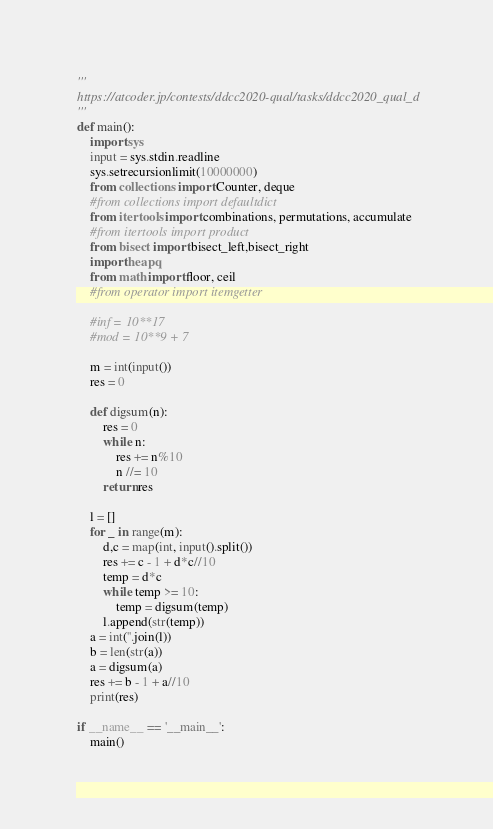Convert code to text. <code><loc_0><loc_0><loc_500><loc_500><_Python_>'''
https://atcoder.jp/contests/ddcc2020-qual/tasks/ddcc2020_qual_d
'''
def main():
    import sys
    input = sys.stdin.readline
    sys.setrecursionlimit(10000000)
    from collections import Counter, deque
    #from collections import defaultdict
    from itertools import combinations, permutations, accumulate
    #from itertools import product
    from bisect import bisect_left,bisect_right
    import heapq
    from math import floor, ceil
    #from operator import itemgetter

    #inf = 10**17
    #mod = 10**9 + 7

    m = int(input())
    res = 0

    def digsum(n):
        res = 0
        while n:
            res += n%10
            n //= 10
        return res
    
    l = []
    for _ in range(m):
        d,c = map(int, input().split())
        res += c - 1 + d*c//10
        temp = d*c
        while temp >= 10:
            temp = digsum(temp)
        l.append(str(temp))
    a = int(''.join(l))
    b = len(str(a))
    a = digsum(a)
    res += b - 1 + a//10
    print(res)

if __name__ == '__main__':
    main()</code> 